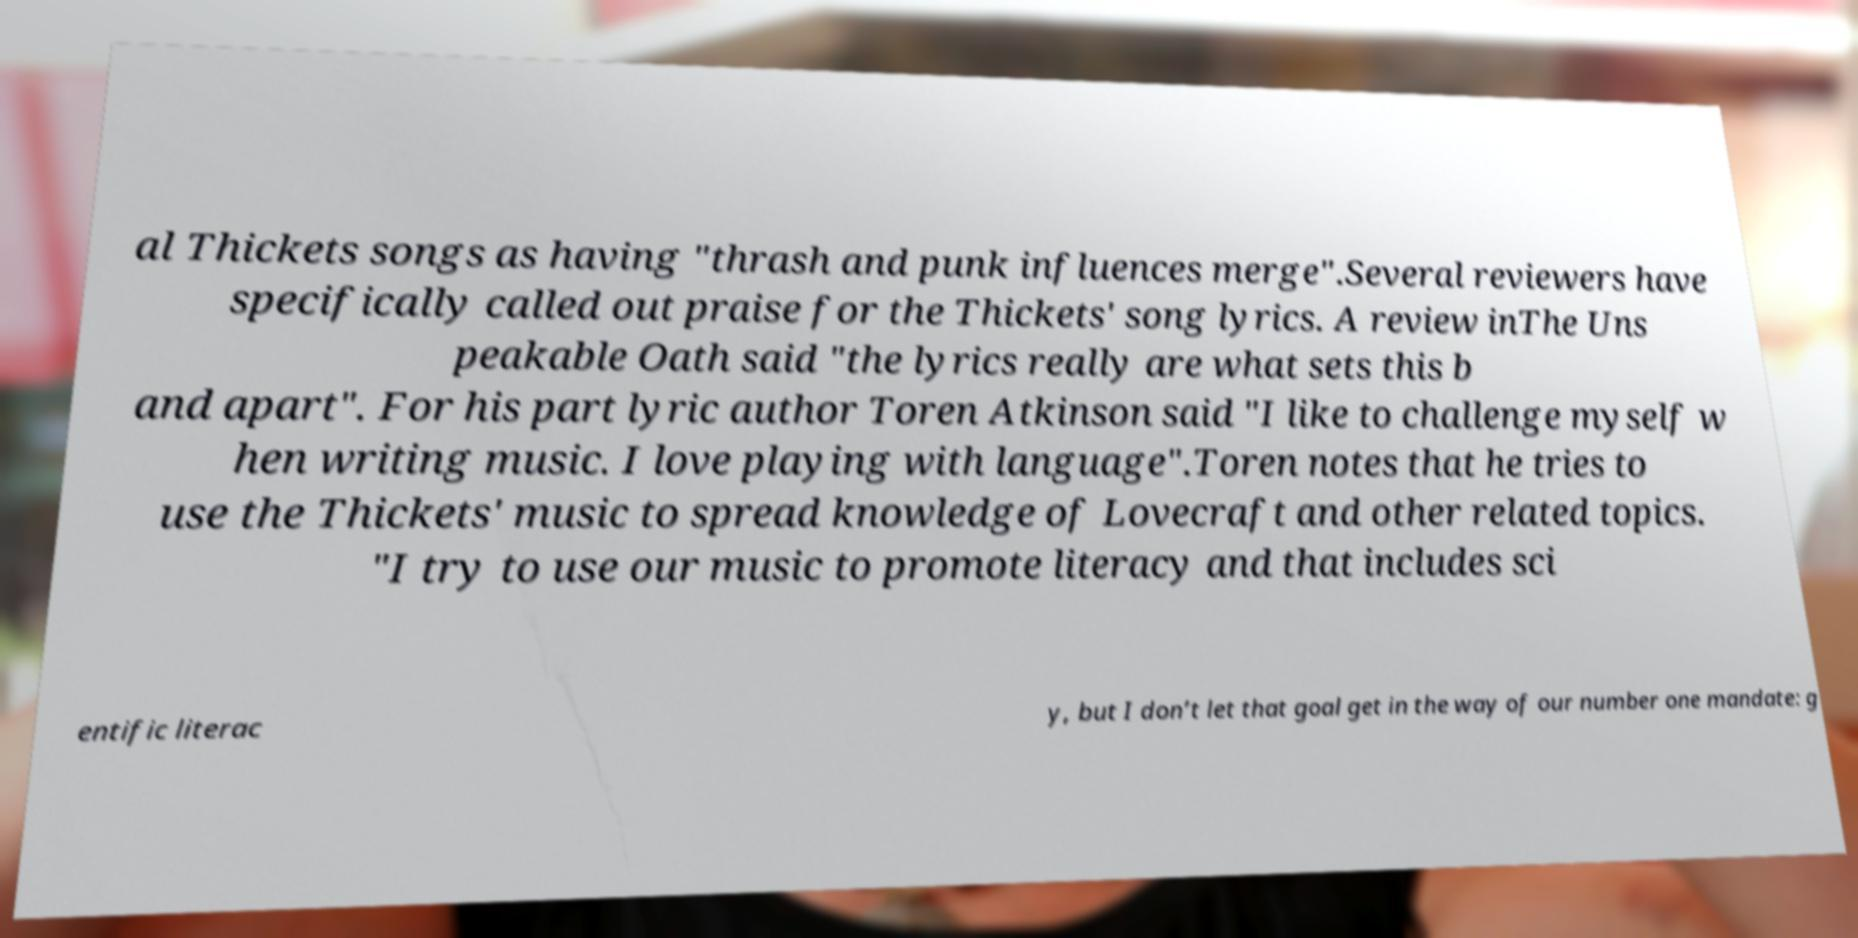Can you read and provide the text displayed in the image?This photo seems to have some interesting text. Can you extract and type it out for me? al Thickets songs as having "thrash and punk influences merge".Several reviewers have specifically called out praise for the Thickets' song lyrics. A review inThe Uns peakable Oath said "the lyrics really are what sets this b and apart". For his part lyric author Toren Atkinson said "I like to challenge myself w hen writing music. I love playing with language".Toren notes that he tries to use the Thickets' music to spread knowledge of Lovecraft and other related topics. "I try to use our music to promote literacy and that includes sci entific literac y, but I don’t let that goal get in the way of our number one mandate: g 